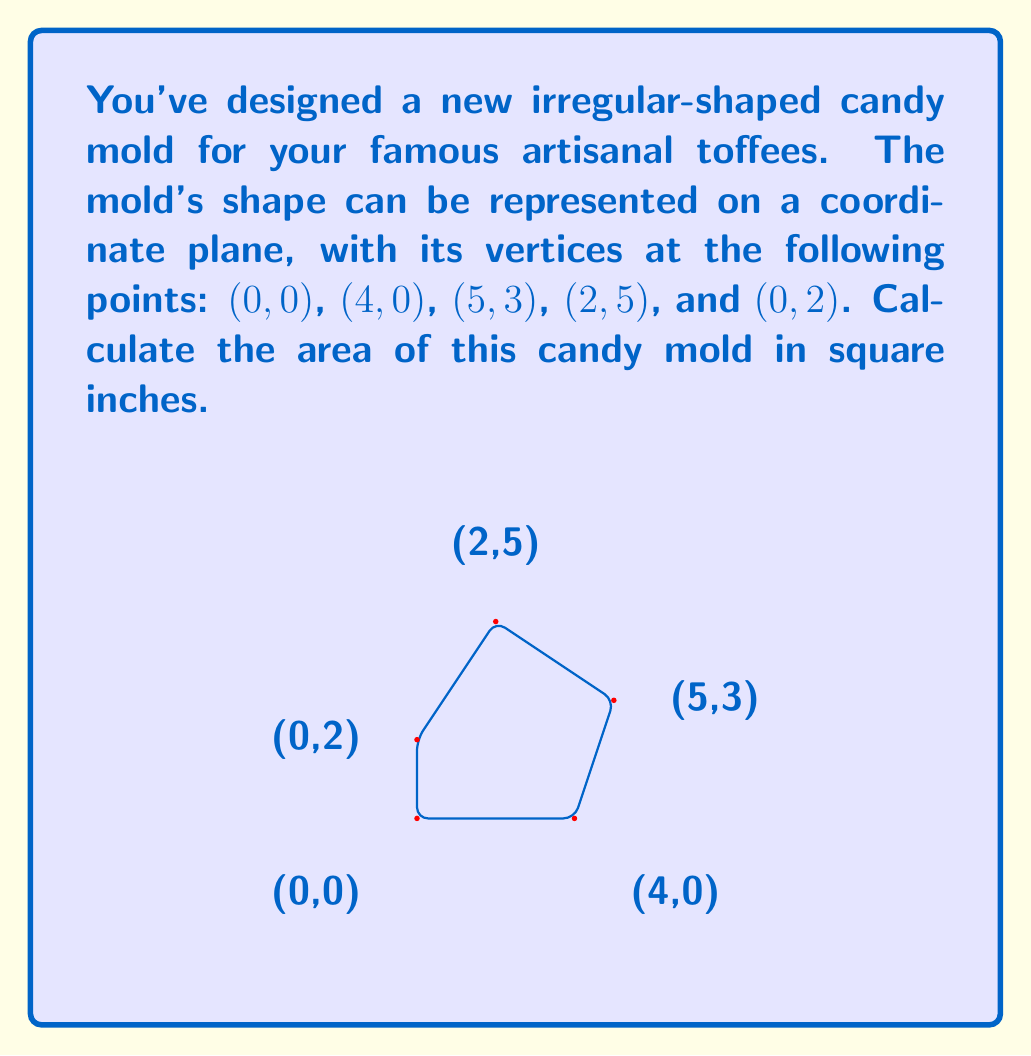Solve this math problem. To calculate the area of this irregular polygon, we can use the Shoelace formula (also known as the surveyor's formula). This method is particularly useful for finding the area of a polygon given its vertices' coordinates.

The Shoelace formula is:

$$ \text{Area} = \frac{1}{2}|\sum_{i=1}^{n-1} (x_iy_{i+1} + x_ny_1) - \sum_{i=1}^{n-1} (x_{i+1}y_i + x_1y_n)| $$

Where $(x_i, y_i)$ are the coordinates of the $i$-th vertex.

Let's apply this formula to our candy mold:

1) First, let's list our coordinates in order:
   $(x_1,y_1) = (0,0)$
   $(x_2,y_2) = (4,0)$
   $(x_3,y_3) = (5,3)$
   $(x_4,y_4) = (2,5)$
   $(x_5,y_5) = (0,2)$

2) Now, let's calculate the first sum:
   $\sum_{i=1}^{n-1} (x_iy_{i+1} + x_ny_1)$
   $= (0 \cdot 0 + 4 \cdot 3 + 5 \cdot 5 + 2 \cdot 2 + 0 \cdot 0)$
   $= 0 + 12 + 25 + 4 + 0 = 41$

3) Next, the second sum:
   $\sum_{i=1}^{n-1} (x_{i+1}y_i + x_1y_n)$
   $= (4 \cdot 0 + 5 \cdot 0 + 2 \cdot 3 + 0 \cdot 5 + 0 \cdot 2)$
   $= 0 + 0 + 6 + 0 + 0 = 6$

4) Now we can subtract and take the absolute value:
   $|41 - 6| = 35$

5) Finally, we divide by 2:
   $\frac{1}{2} \cdot 35 = 17.5$

Therefore, the area of the candy mold is 17.5 square inches.
Answer: 17.5 square inches 